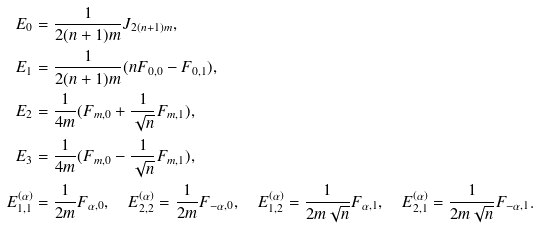Convert formula to latex. <formula><loc_0><loc_0><loc_500><loc_500>E _ { 0 } & = \frac { 1 } { 2 ( n + 1 ) m } J _ { 2 ( n + 1 ) m } , \\ E _ { 1 } & = \frac { 1 } { 2 ( n + 1 ) m } ( n F _ { 0 , 0 } - F _ { 0 , 1 } ) , \\ E _ { 2 } & = \frac { 1 } { 4 m } ( F _ { m , 0 } + \frac { 1 } { \sqrt { n } } F _ { m , 1 } ) , \\ E _ { 3 } & = \frac { 1 } { 4 m } ( F _ { m , 0 } - \frac { 1 } { \sqrt { n } } F _ { m , 1 } ) , \\ E _ { 1 , 1 } ^ { ( \alpha ) } & = \frac { 1 } { 2 m } F _ { \alpha , 0 } , \quad E _ { 2 , 2 } ^ { ( \alpha ) } = \frac { 1 } { 2 m } F _ { - \alpha , 0 } , \quad E _ { 1 , 2 } ^ { ( \alpha ) } = \frac { 1 } { 2 m \sqrt { n } } F _ { \alpha , 1 } , \quad E _ { 2 , 1 } ^ { ( \alpha ) } = \frac { 1 } { 2 m \sqrt { n } } F _ { - \alpha , 1 } .</formula> 